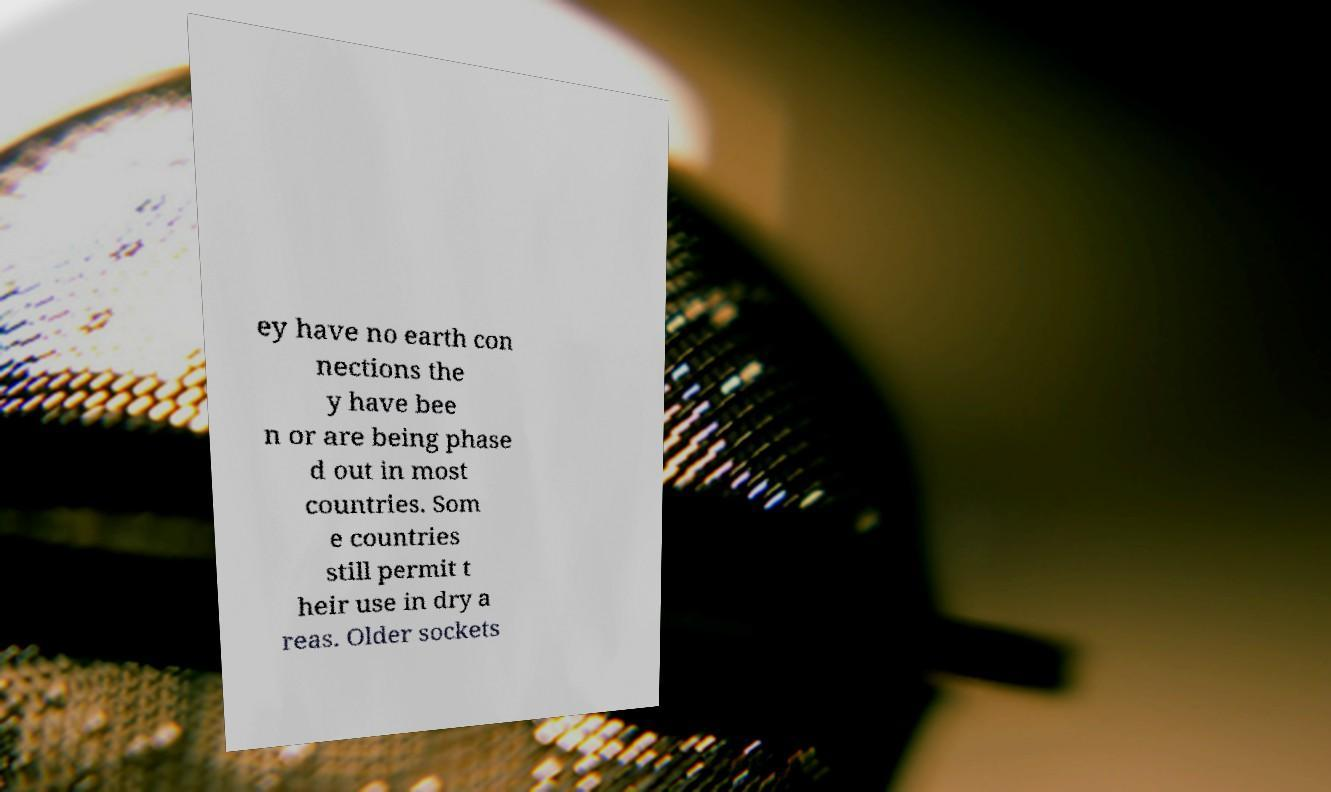Could you extract and type out the text from this image? ey have no earth con nections the y have bee n or are being phase d out in most countries. Som e countries still permit t heir use in dry a reas. Older sockets 